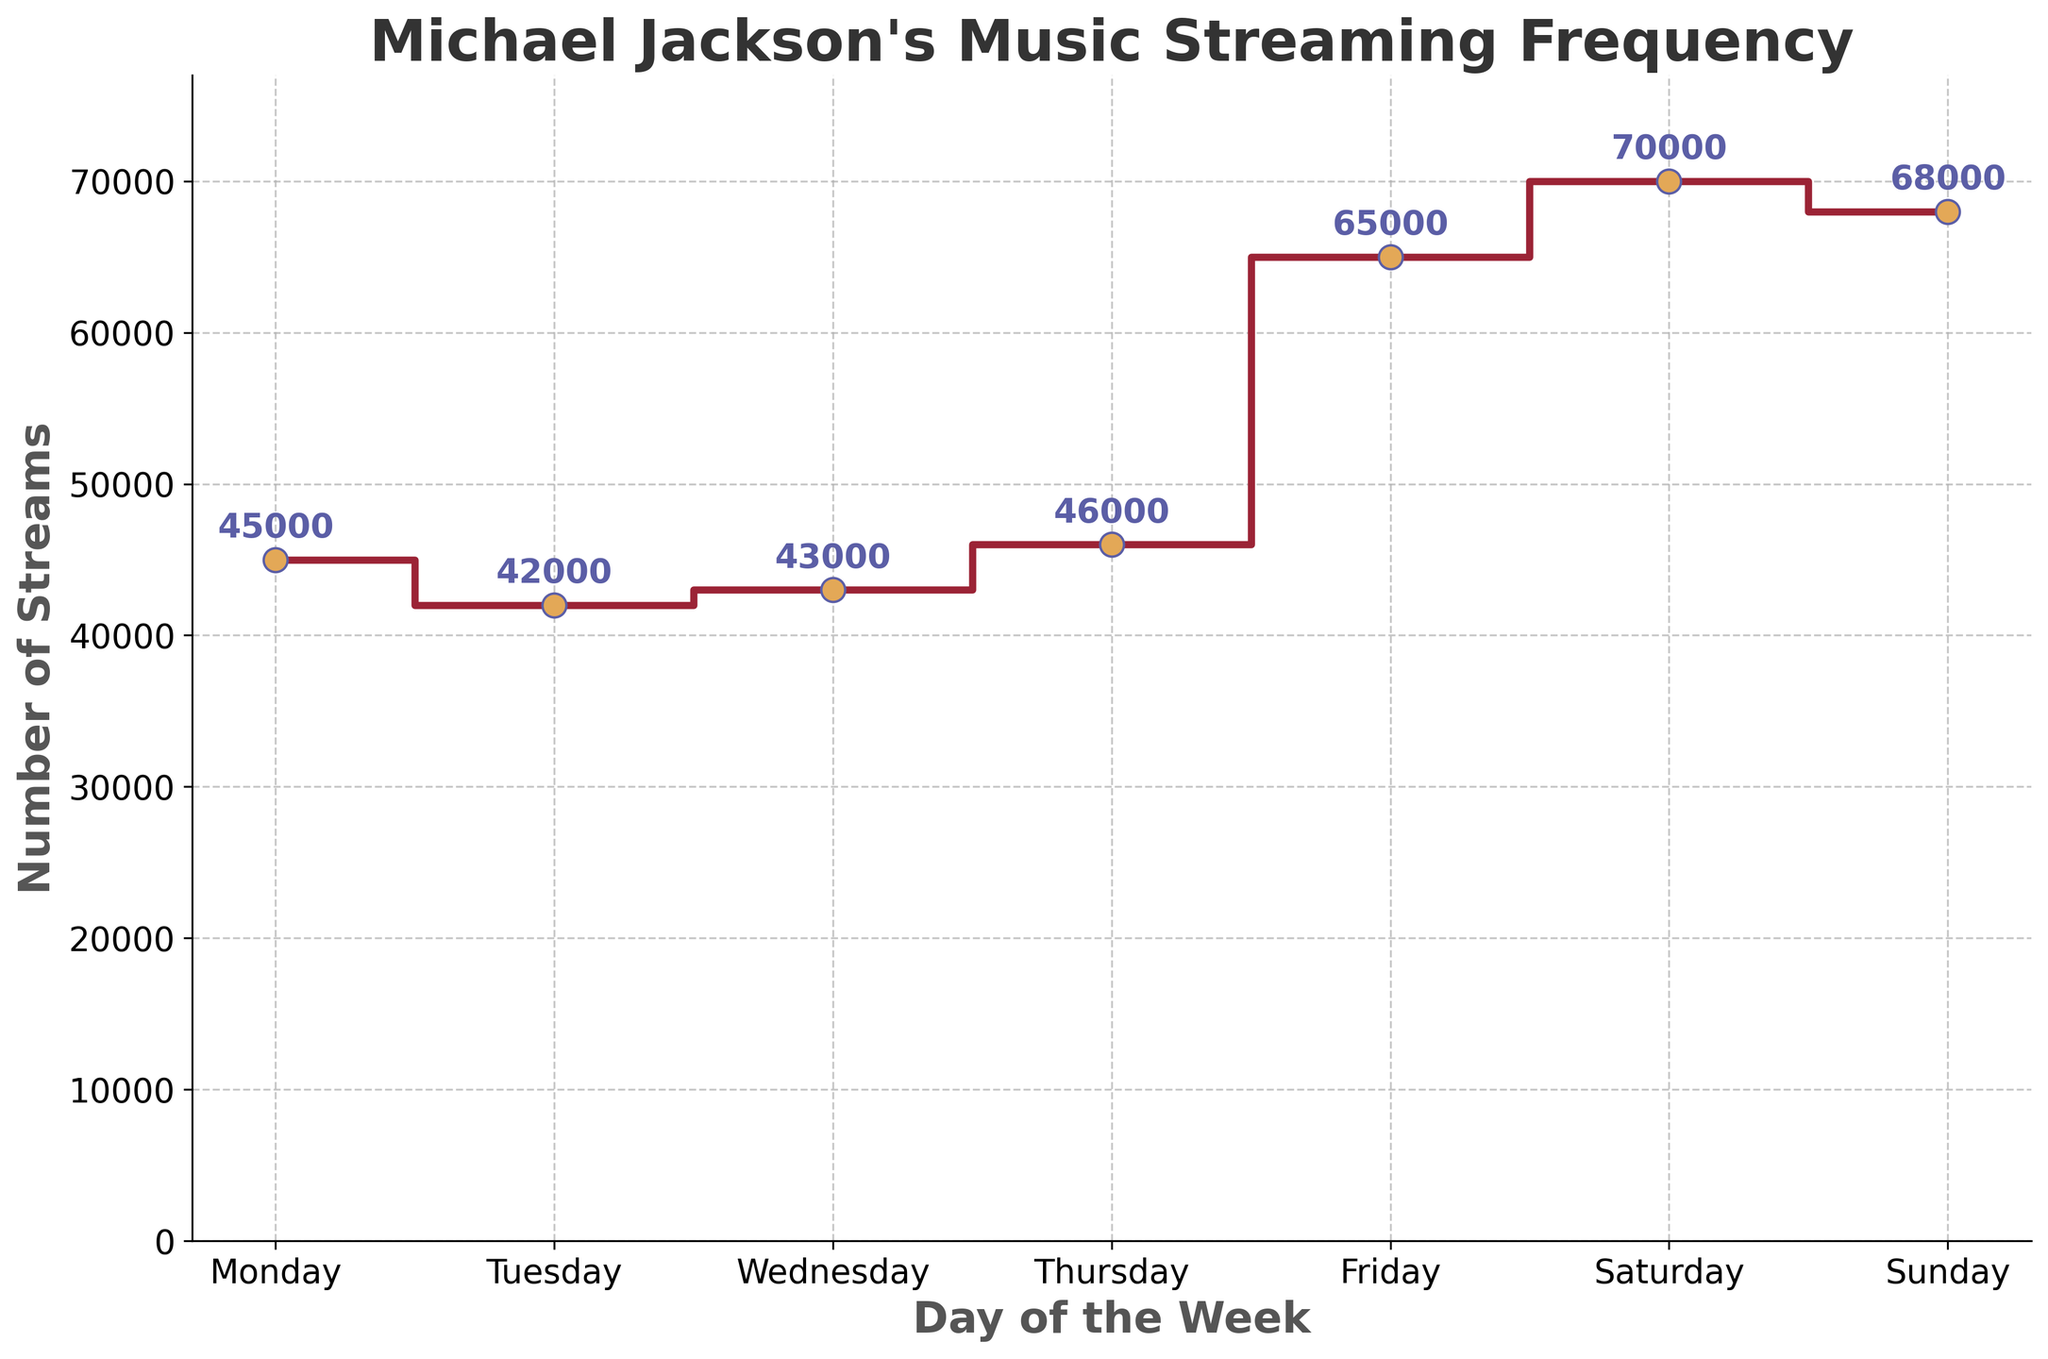What's the title of the figure? The title of the figure is displayed at the top and provides a concise description of the plot's focus.
Answer: Michael Jackson's Music Streaming Frequency What does the y-axis represent? The y-axis is labeled to indicate what data it is showing, which in this case is the number of streams.
Answer: Number of Streams What is the number of streams on Saturday? The number of streams for each day is marked with a dot and a numeric label close to the step line. You can directly read the value.
Answer: 70,000 Which day of the week has the lowest number of streams? By examining the y-values for each day, you can identify the day with the smallest number. Tuesday has the lowest value.
Answer: Tuesday How many more streams are there on Sunday compared to Wednesday? Find the value for Sunday (68,000) and Wednesday (43,000). Subtract the streams on Wednesday from Sunday to get the difference: 68,000 - 43,000 = 25,000.
Answer: 25,000 On which days are the number of streams greater than 60,000? By comparing each day's streams against 60,000, you will find Saturday (70,000) and Sunday (68,000) both exceed this value.
Answer: Saturday and Sunday What is the total number of streams from Monday to Friday? Add the streams for each day from Monday to Friday: 45,000 + 42,000 + 43,000 + 46,000 + 65,000 = 241,000.
Answer: 241,000 How does the streaming frequency trend from Monday to Sunday? Notice the general pattern or trend. It starts lower on Monday, fluctuates through the week, and increases significantly towards the weekend.
Answer: Increases towards the weekend What is the average number of streams over the week? Sum all the streams and divide by the number of days: (45,000 + 42,000 + 43,000 + 46,000 + 65,000 + 70,000 + 68,000) / 7 ≈ 54,143.
Answer: ≈ 54,143 Is the number of streams on Friday greater than the number of streams on Tuesday and Wednesday combined? First calculate the combined streams for Tuesday and Wednesday: 42,000 + 43,000 = 85,000. Compare this against Friday's 65,000. 65,000 is less than 85,000.
Answer: No 